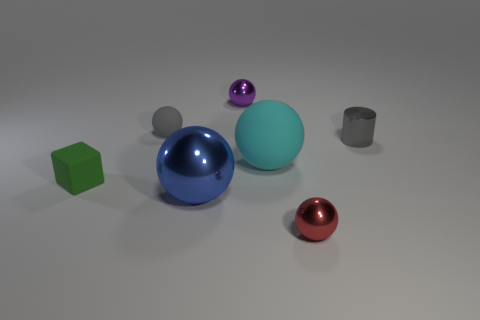Subtract all red spheres. How many spheres are left? 4 Subtract all red metallic balls. How many balls are left? 4 Subtract all brown balls. Subtract all brown cylinders. How many balls are left? 5 Add 3 tiny purple objects. How many objects exist? 10 Subtract all cubes. How many objects are left? 6 Subtract all cyan balls. Subtract all small gray spheres. How many objects are left? 5 Add 4 large cyan rubber balls. How many large cyan rubber balls are left? 5 Add 3 big red shiny cylinders. How many big red shiny cylinders exist? 3 Subtract 0 green cylinders. How many objects are left? 7 